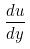Convert formula to latex. <formula><loc_0><loc_0><loc_500><loc_500>\frac { d u } { d y }</formula> 